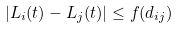Convert formula to latex. <formula><loc_0><loc_0><loc_500><loc_500>| L _ { i } ( t ) - L _ { j } ( t ) | \leq f ( d _ { i j } )</formula> 